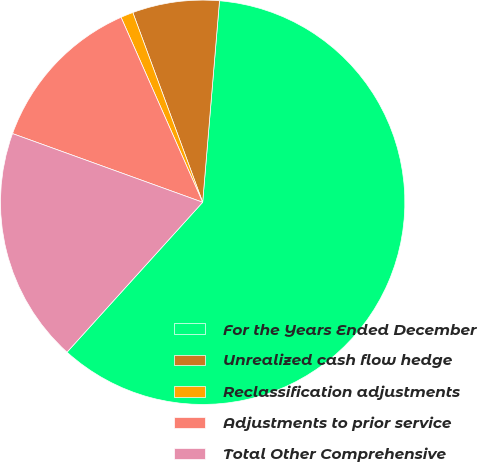Convert chart to OTSL. <chart><loc_0><loc_0><loc_500><loc_500><pie_chart><fcel>For the Years Ended December<fcel>Unrealized cash flow hedge<fcel>Reclassification adjustments<fcel>Adjustments to prior service<fcel>Total Other Comprehensive<nl><fcel>60.38%<fcel>6.94%<fcel>1.0%<fcel>12.87%<fcel>18.81%<nl></chart> 